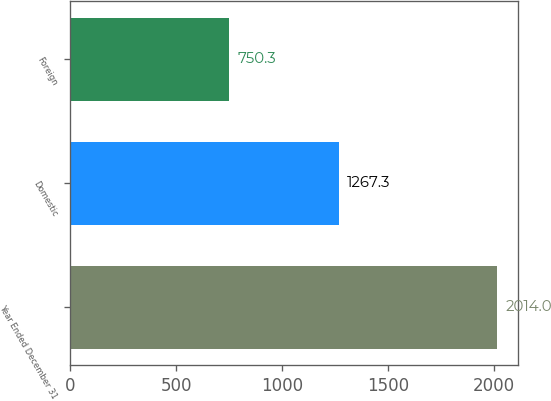Convert chart to OTSL. <chart><loc_0><loc_0><loc_500><loc_500><bar_chart><fcel>Year Ended December 31<fcel>Domestic<fcel>Foreign<nl><fcel>2014<fcel>1267.3<fcel>750.3<nl></chart> 